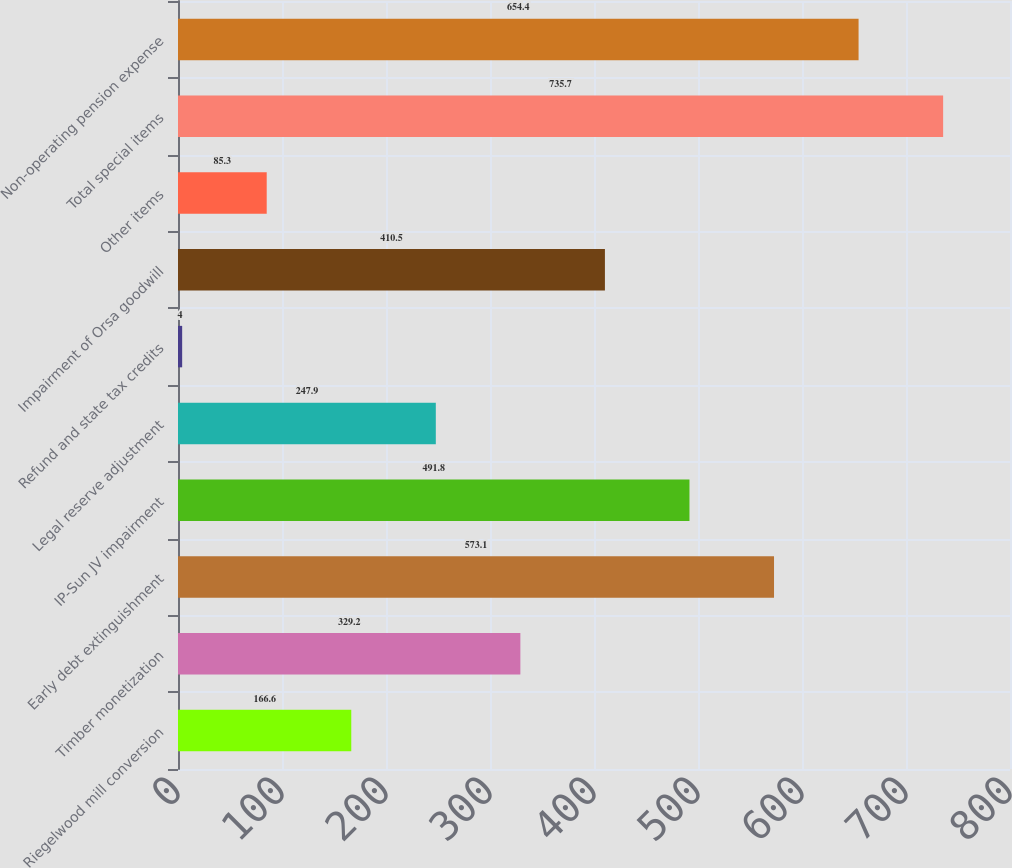Convert chart. <chart><loc_0><loc_0><loc_500><loc_500><bar_chart><fcel>Riegelwood mill conversion<fcel>Timber monetization<fcel>Early debt extinguishment<fcel>IP-Sun JV impairment<fcel>Legal reserve adjustment<fcel>Refund and state tax credits<fcel>Impairment of Orsa goodwill<fcel>Other items<fcel>Total special items<fcel>Non-operating pension expense<nl><fcel>166.6<fcel>329.2<fcel>573.1<fcel>491.8<fcel>247.9<fcel>4<fcel>410.5<fcel>85.3<fcel>735.7<fcel>654.4<nl></chart> 